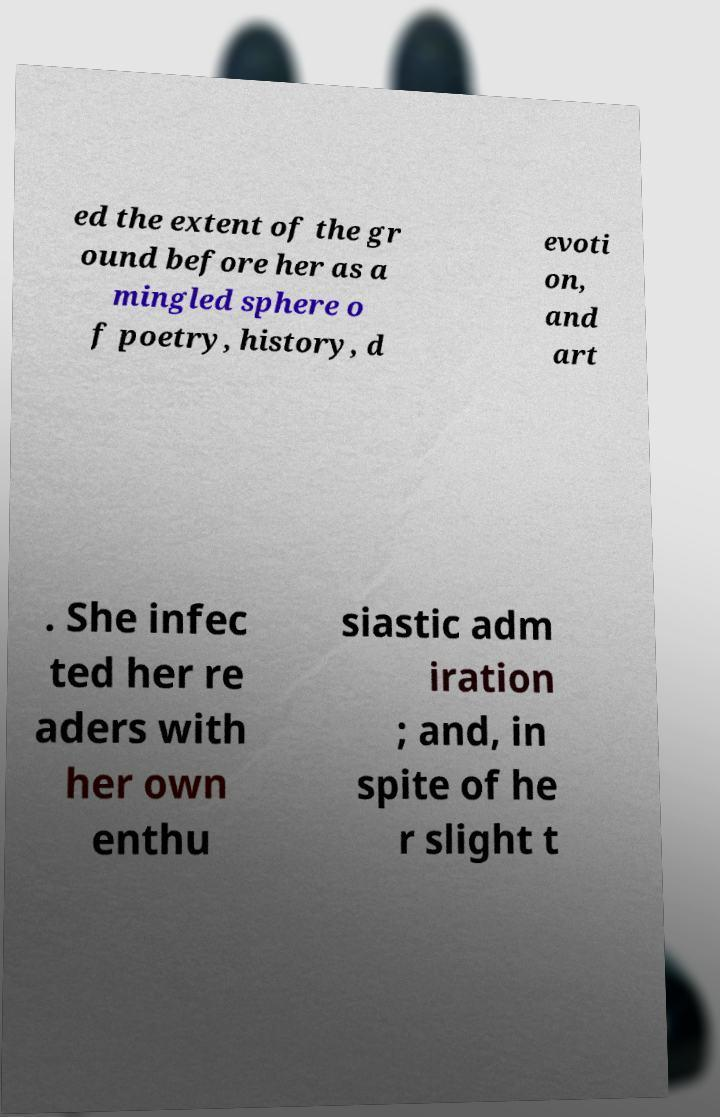There's text embedded in this image that I need extracted. Can you transcribe it verbatim? ed the extent of the gr ound before her as a mingled sphere o f poetry, history, d evoti on, and art . She infec ted her re aders with her own enthu siastic adm iration ; and, in spite of he r slight t 